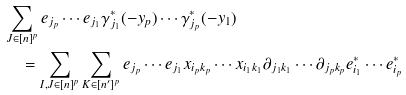Convert formula to latex. <formula><loc_0><loc_0><loc_500><loc_500>& \sum _ { J \in [ n ] ^ { p } } e _ { j _ { p } } \cdots e _ { j _ { 1 } } \gamma ^ { * } _ { j _ { 1 } } ( - y _ { p } ) \cdots \gamma ^ { * } _ { j _ { p } } ( - y _ { 1 } ) \\ & \quad = \sum _ { I , J \in [ n ] ^ { p } } \sum _ { K \in [ n ^ { \prime } ] ^ { p } } e _ { j _ { p } } \cdots e _ { j _ { 1 } } x _ { i _ { p } k _ { p } } \cdots x _ { i _ { 1 } k _ { 1 } } \partial _ { j _ { 1 } k _ { 1 } } \cdots \partial _ { j _ { p } k _ { p } } e ^ { * } _ { i _ { 1 } } \cdots e ^ { * } _ { i _ { p } }</formula> 